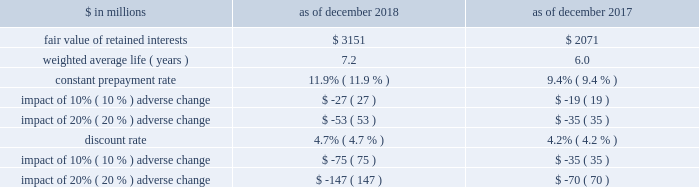The goldman sachs group , inc .
And subsidiaries notes to consolidated financial statements 2030 purchased interests represent senior and subordinated interests , purchased in connection with secondary market-making activities , in securitization entities in which the firm also holds retained interests .
2030 substantially all of the total outstanding principal amount and total retained interests relate to securitizations during 2014 and thereafter as of december 2018 , and relate to securitizations during 2012 and thereafter as of december 2017 .
2030 the fair value of retained interests was $ 3.28 billion as of december 2018 and $ 2.13 billion as of december 2017 .
In addition to the interests in the table above , the firm had other continuing involvement in the form of derivative transactions and commitments with certain nonconsolidated vies .
The carrying value of these derivatives and commitments was a net asset of $ 75 million as of december 2018 and $ 86 million as of december 2017 , and the notional amount of these derivatives and commitments was $ 1.09 billion as of december 2018 and $ 1.26 billion as of december 2017 .
The notional amounts of these derivatives and commitments are included in maximum exposure to loss in the nonconsolidated vie table in note 12 .
The table below presents information about the weighted average key economic assumptions used in measuring the fair value of mortgage-backed retained interests. .
In the table above : 2030 amounts do not reflect the benefit of other financial instruments that are held to mitigate risks inherent in these retained interests .
2030 changes in fair value based on an adverse variation in assumptions generally cannot be extrapolated because the relationship of the change in assumptions to the change in fair value is not usually linear .
2030 the impact of a change in a particular assumption is calculated independently of changes in any other assumption .
In practice , simultaneous changes in assumptions might magnify or counteract the sensitivities disclosed above .
2030 the constant prepayment rate is included only for positions for which it is a key assumption in the determination of fair value .
2030 the discount rate for retained interests that relate to u.s .
Government agency-issued collateralized mortgage obligations does not include any credit loss .
Expected credit loss assumptions are reflected in the discount rate for the remainder of retained interests .
The firm has other retained interests not reflected in the table above with a fair value of $ 133 million and a weighted average life of 4.2 years as of december 2018 , and a fair value of $ 56 million and a weighted average life of 4.5 years as of december 2017 .
Due to the nature and fair value of certain of these retained interests , the weighted average assumptions for constant prepayment and discount rates and the related sensitivity to adverse changes are not meaningful as of both december 2018 and december 2017 .
The firm 2019s maximum exposure to adverse changes in the value of these interests is the carrying value of $ 133 million as of december 2018 and $ 56 million as of december 2017 .
Note 12 .
Variable interest entities a variable interest in a vie is an investment ( e.g. , debt or equity ) or other interest ( e.g. , derivatives or loans and lending commitments ) that will absorb portions of the vie 2019s expected losses and/or receive portions of the vie 2019s expected residual returns .
The firm 2019s variable interests in vies include senior and subordinated debt ; loans and lending commitments ; limited and general partnership interests ; preferred and common equity ; derivatives that may include foreign currency , equity and/or credit risk ; guarantees ; and certain of the fees the firm receives from investment funds .
Certain interest rate , foreign currency and credit derivatives the firm enters into with vies are not variable interests because they create , rather than absorb , risk .
Vies generally finance the purchase of assets by issuing debt and equity securities that are either collateralized by or indexed to the assets held by the vie .
The debt and equity securities issued by a vie may include tranches of varying levels of subordination .
The firm 2019s involvement with vies includes securitization of financial assets , as described in note 11 , and investments in and loans to other types of vies , as described below .
See note 11 for further information about securitization activities , including the definition of beneficial interests .
See note 3 for the firm 2019s consolidation policies , including the definition of a vie .
Goldman sachs 2018 form 10-k 149 .
What is the net change in the other retained interests not reflected in the table during 2018 , in millions? 
Computations: (133 - 56)
Answer: 77.0. 